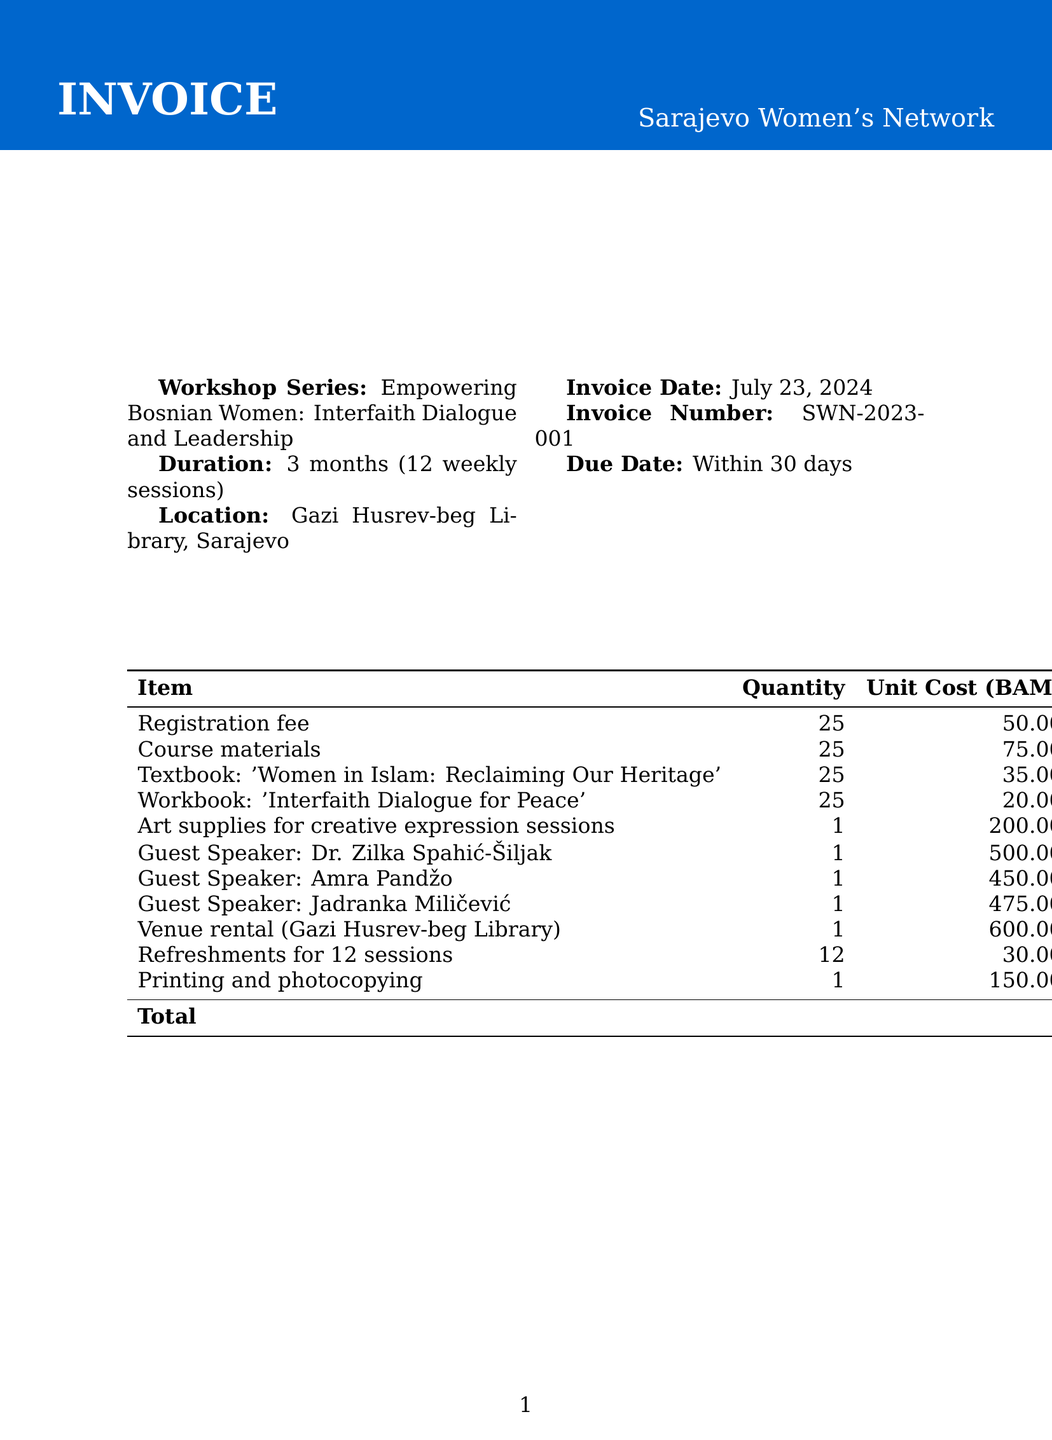what is the workshop series name? The workshop series name is a specific identifier of the event that is mentioned prominently in the document.
Answer: Empowering Bosnian Women: Interfaith Dialogue and Leadership who is the organizer of the workshop series? The organizer is mentioned in the document as the entity responsible for the event.
Answer: Sarajevo Women's Network how many weekly sessions are there? The number of weekly sessions is detailed in the workshop duration section of the document.
Answer: 12 what is the registration fee? The registration fee is clearly listed as a separate cost in the fees section of the invoice.
Answer: 50 how much does the textbook cost per unit? The cost per unit for the textbook is specified in the materials section of the document.
Answer: 35 what is the total cost of the invoice? The total cost of the invoice is summarized at the end of the document as the final amount due.
Answer: 4785 how many guest speakers are included in the invoice? The number of guest speakers can be counted from the guest speaker section within the document.
Answer: 3 what is the venue rental cost? The cost for renting the venue is shown in the additional costs section of the document.
Answer: 600 what is the item for the creative expression sessions? The item associated with the creative expression sessions is specifically listed in the materials portion of the invoice.
Answer: Art supplies for creative expression sessions 